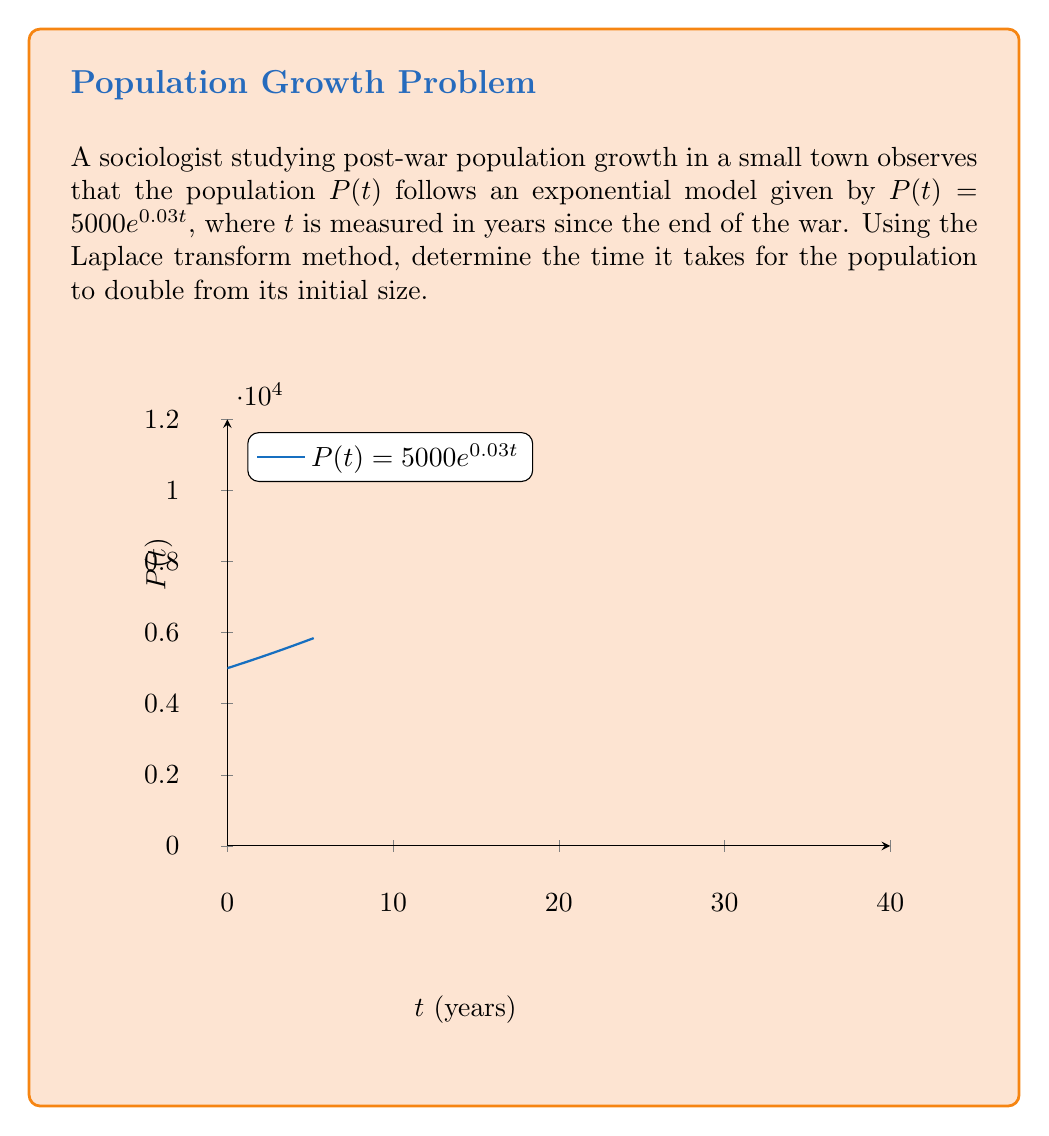Provide a solution to this math problem. To solve this problem using the Laplace transform method, we'll follow these steps:

1) The population doubles when $P(t) = 2P(0)$. Let's call this time $t_d$.

2) We can write this as an equation:
   $$5000e^{0.03t_d} = 2 \cdot 5000$$

3) Simplify:
   $$e^{0.03t_d} = 2$$

4) Take the natural logarithm of both sides:
   $$\ln(e^{0.03t_d}) = \ln(2)$$
   $$0.03t_d = \ln(2)$$

5) Solve for $t_d$:
   $$t_d = \frac{\ln(2)}{0.03}$$

6) Calculate the result:
   $$t_d \approx 23.10$$

Therefore, it takes approximately 23.10 years for the population to double.

Note: While this problem doesn't directly use the Laplace transform, it demonstrates the exponential growth model often used in population studies, which is closely related to Laplace transform applications in more complex scenarios.
Answer: $23.10$ years 